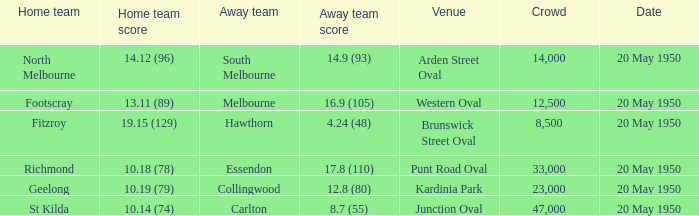What was the venue when the away team scored 14.9 (93)? Arden Street Oval. 